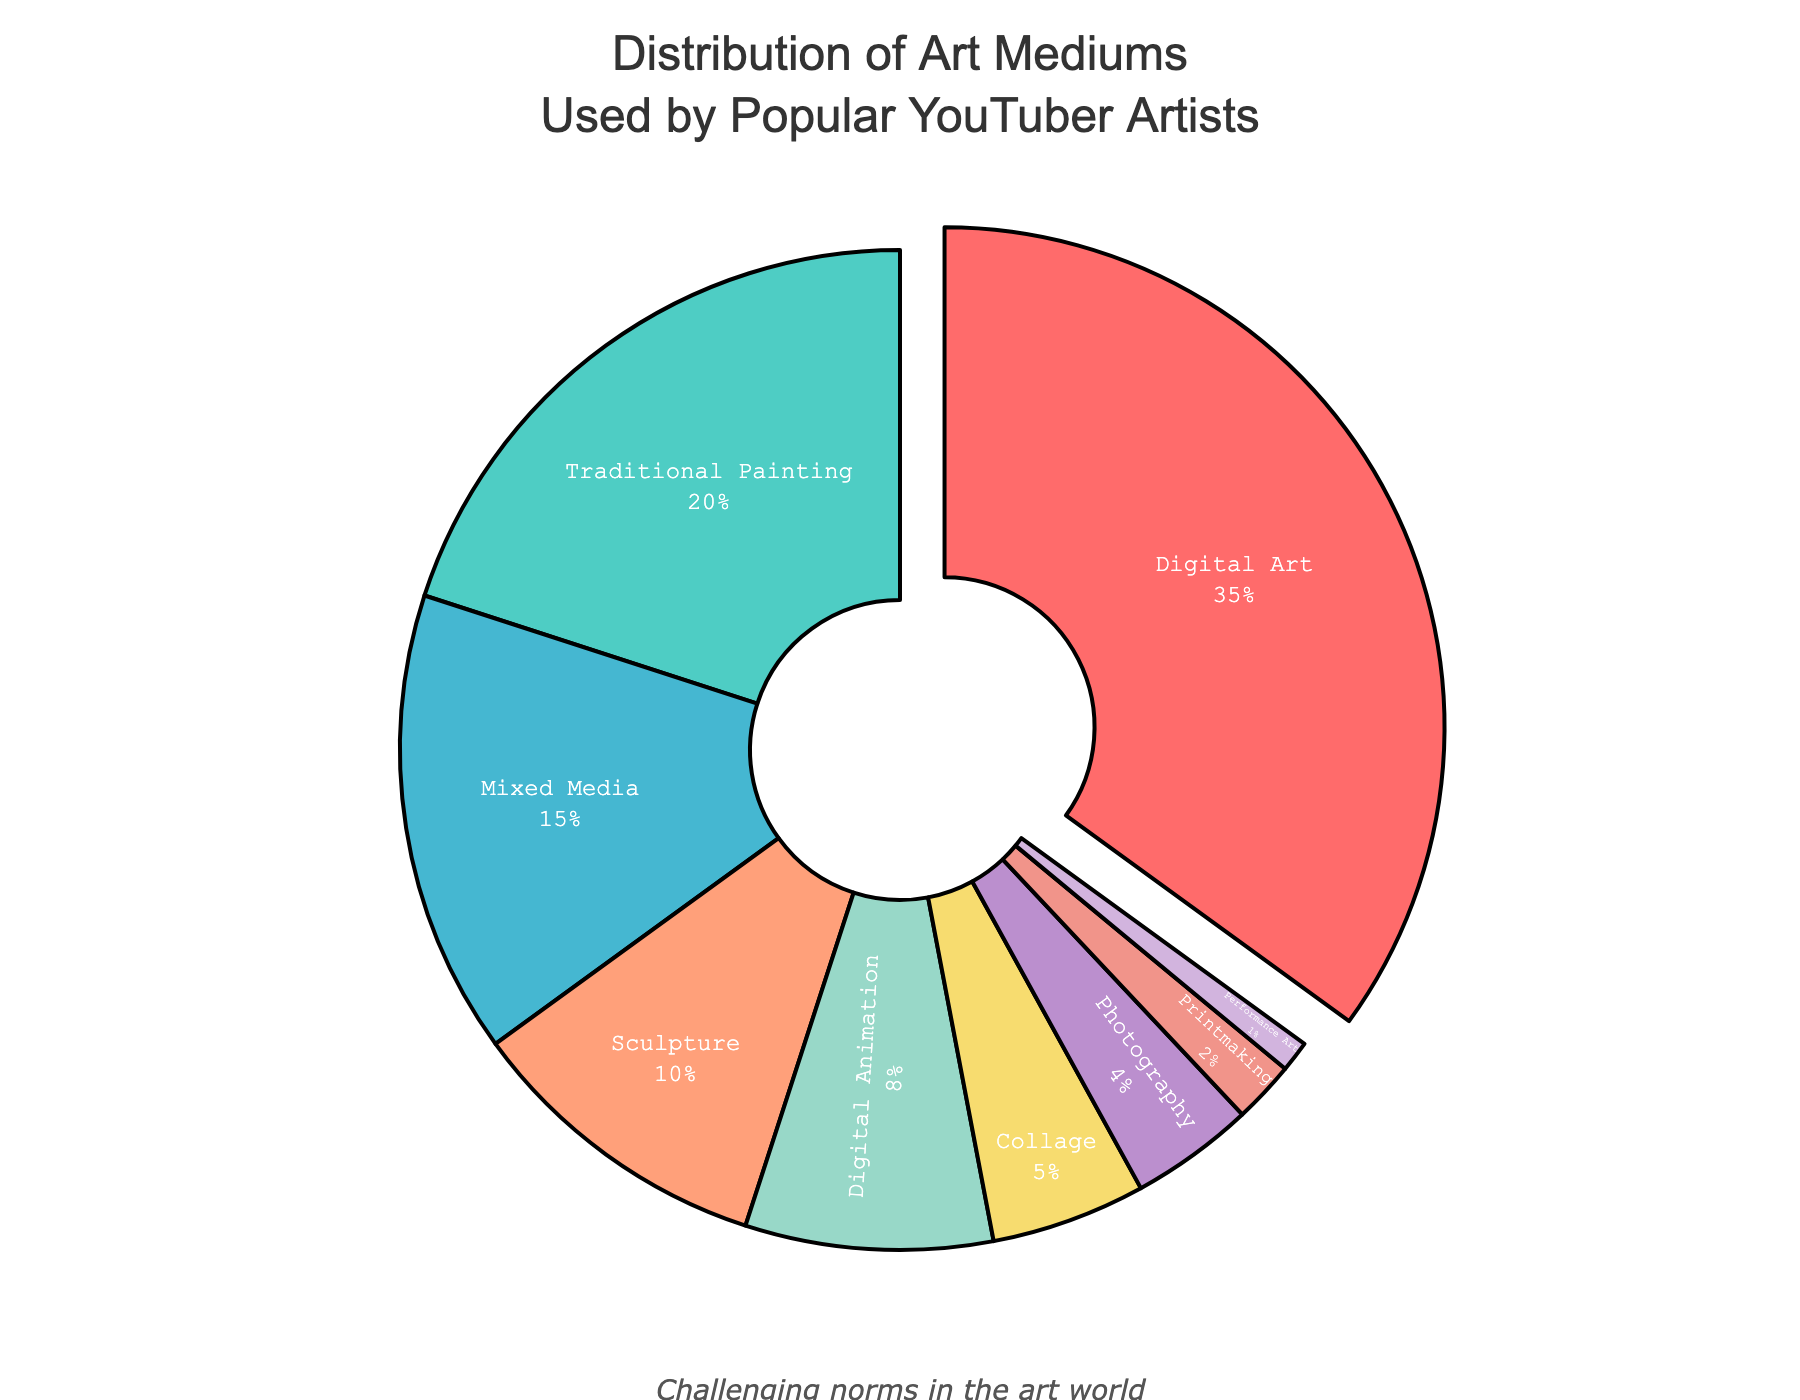Which art medium is most commonly used by popular YouTuber artists? The pie chart shows the percentage distribution of different art mediums. The largest segment, which is pulled out slightly, represents the most common medium. This medium is Digital Art with 35%.
Answer: Digital Art Compare the percentage of Digital Animation and Sculpture. Which one is higher? The pie chart segments for Digital Animation and Sculpture are compared. Digital Animation has 8%, while Sculpture has 10%.
Answer: Sculpture What is the combined percentage of Mixed Media and Traditional Painting? The percentages for Mixed Media and Traditional Painting are added together. Mixed Media is 15% and Traditional Painting is 20%, so the combined percentage is 15% + 20% = 35%.
Answer: 35% Which medium has the smallest percentage, and what is its value? By observing the pie chart, Performance Art is the smallest segment with a percentage of 1%.
Answer: Performance Art, 1% How much more common is Digital Art compared to Photography? The percentage for Digital Art is 35%, and for Photography, it is 4%. Calculate the difference: 35% - 4% = 31%.
Answer: 31% What is the percentage difference between the most commonly and least commonly used art mediums? The most commonly used medium is Digital Art with 35%, and the least is Performance Art with 1%. The percentage difference is 35% - 1% = 34%.
Answer: 34% Identify the mediums that together cover more than half of the total distribution. Combining the largest percentages: Digital Art (35%), Traditional Painting (20%). Adding them gives 35% + 20% = 55%, which is more than 50%.
Answer: Digital Art, Traditional Painting Which medium has a 5% usage among YouTuber artists? The pie chart shows that Collage has a 5% share.
Answer: Collage Are there more types of digital or non-digital art mediums used by YouTuber artists? List the types. Digital art mediums: Digital Art (35%), Digital Animation (8%). Non-digital art mediums: Traditional Painting (20%), Mixed Media (15%), Sculpture (10%), Collage (5%), Photography (4%), Printmaking (2%), Performance Art (1%). There are more types of non-digital art mediums.
Answer: Non-digital: Traditional Painting, Mixed Media, Sculpture, Collage, Photography, Printmaking, Performance Art Compare the total percentage of Digital Art and Digital Animation with that of non-digital mediums. The total percentage for Digital Art (35%) and Digital Animation (8%) is 35% + 8% = 43%. For non-digital mediums: Traditional Painting (20%) + Mixed Media (15%) + Sculpture (10%) + Collage (5%) + Photography (4%) + Printmaking (2%) + Performance Art (1%) = 57%. Non-digital makes up a higher percentage.
Answer: Non-digital 57%, digital 43% 